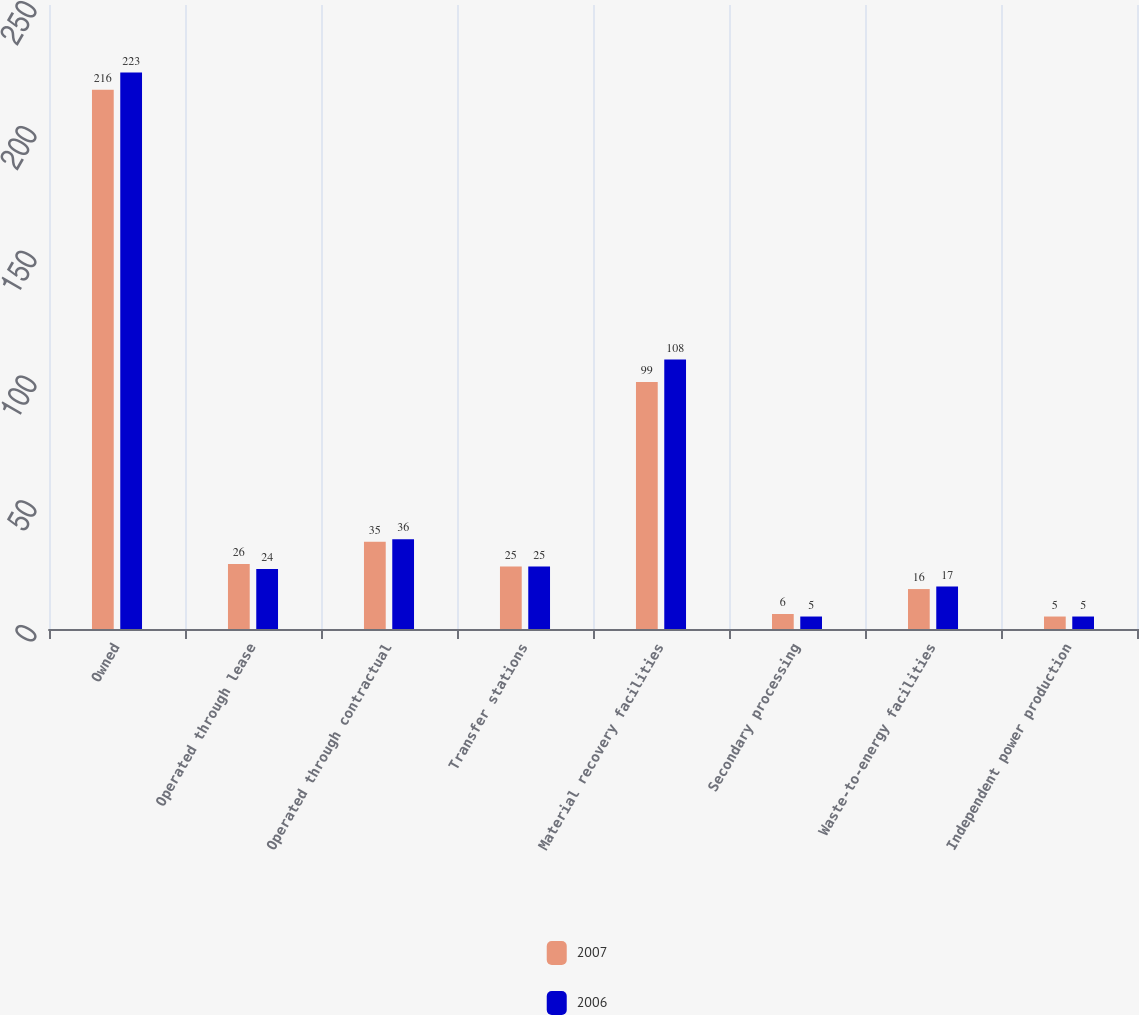Convert chart to OTSL. <chart><loc_0><loc_0><loc_500><loc_500><stacked_bar_chart><ecel><fcel>Owned<fcel>Operated through lease<fcel>Operated through contractual<fcel>Transfer stations<fcel>Material recovery facilities<fcel>Secondary processing<fcel>Waste-to-energy facilities<fcel>Independent power production<nl><fcel>2007<fcel>216<fcel>26<fcel>35<fcel>25<fcel>99<fcel>6<fcel>16<fcel>5<nl><fcel>2006<fcel>223<fcel>24<fcel>36<fcel>25<fcel>108<fcel>5<fcel>17<fcel>5<nl></chart> 